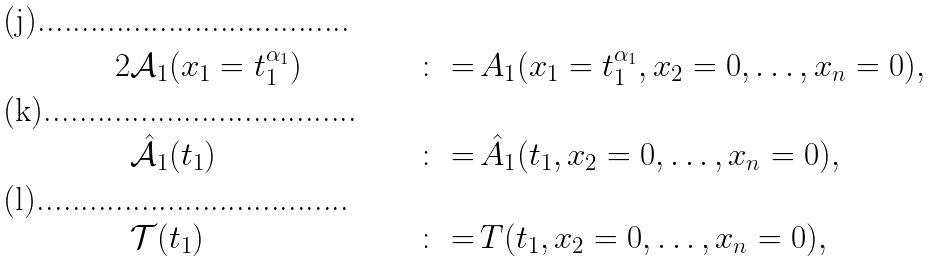Convert formula to latex. <formula><loc_0><loc_0><loc_500><loc_500>2 & \mathcal { A } _ { 1 } ( x _ { 1 } = t _ { 1 } ^ { \alpha _ { 1 } } ) & \, \colon = \, & A _ { 1 } ( x _ { 1 } = t _ { 1 } ^ { \alpha _ { 1 } } , x _ { 2 } = 0 , \dots , x _ { n } = 0 ) , \\ & \hat { \mathcal { A } } _ { 1 } ( t _ { 1 } ) & \, \colon = \, & \hat { A } _ { 1 } ( t _ { 1 } , x _ { 2 } = 0 , \dots , x _ { n } = 0 ) , \\ & \mathcal { T } ( t _ { 1 } ) & \, \colon = \, & T ( t _ { 1 } , x _ { 2 } = 0 , \dots , x _ { n } = 0 ) ,</formula> 